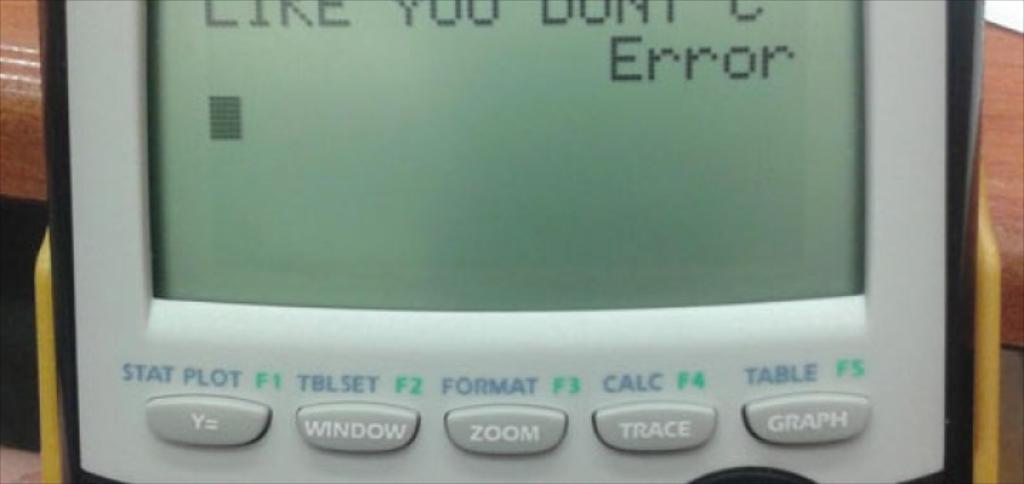<image>
Write a terse but informative summary of the picture. An error message is showing on a device's screen. 